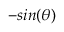Convert formula to latex. <formula><loc_0><loc_0><loc_500><loc_500>- \sin ( \theta )</formula> 